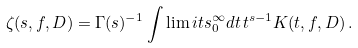Convert formula to latex. <formula><loc_0><loc_0><loc_500><loc_500>\zeta ( s , f , D ) = \Gamma ( s ) ^ { - 1 } \int \lim i t s _ { 0 } ^ { \infty } d t \, t ^ { s - 1 } K ( t , f , D ) \, .</formula> 